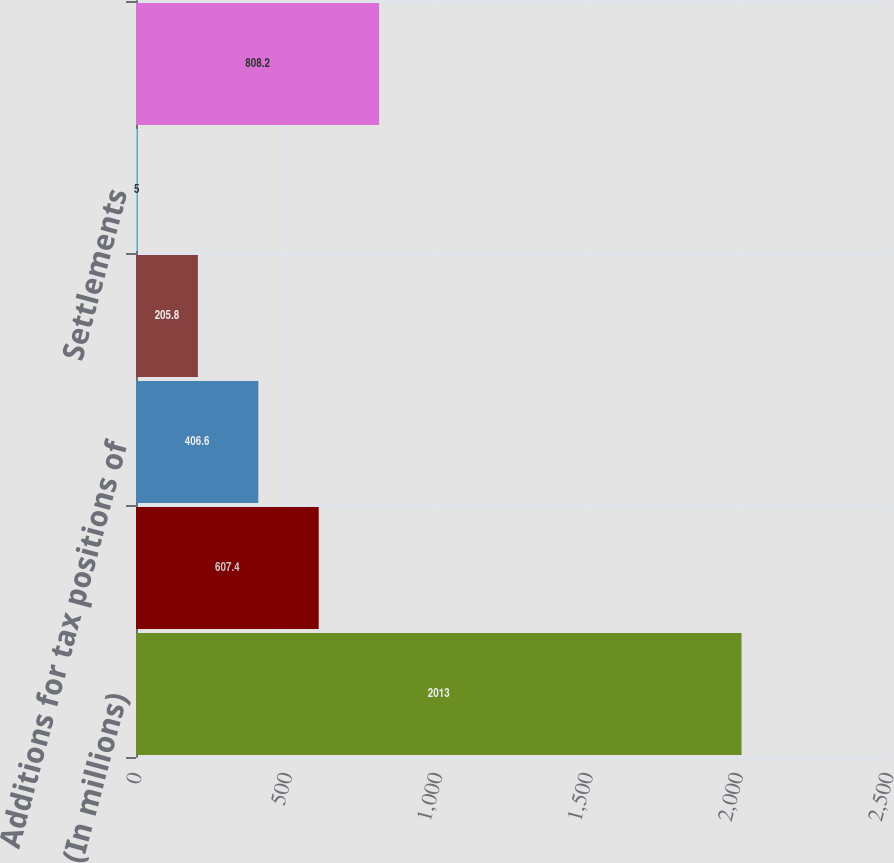Convert chart. <chart><loc_0><loc_0><loc_500><loc_500><bar_chart><fcel>(In millions)<fcel>Beginning balance<fcel>Additions for tax positions of<fcel>Reductions for tax positions<fcel>Settlements<fcel>Ending balance<nl><fcel>2013<fcel>607.4<fcel>406.6<fcel>205.8<fcel>5<fcel>808.2<nl></chart> 